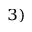Convert formula to latex. <formula><loc_0><loc_0><loc_500><loc_500>^ { 3 ) }</formula> 